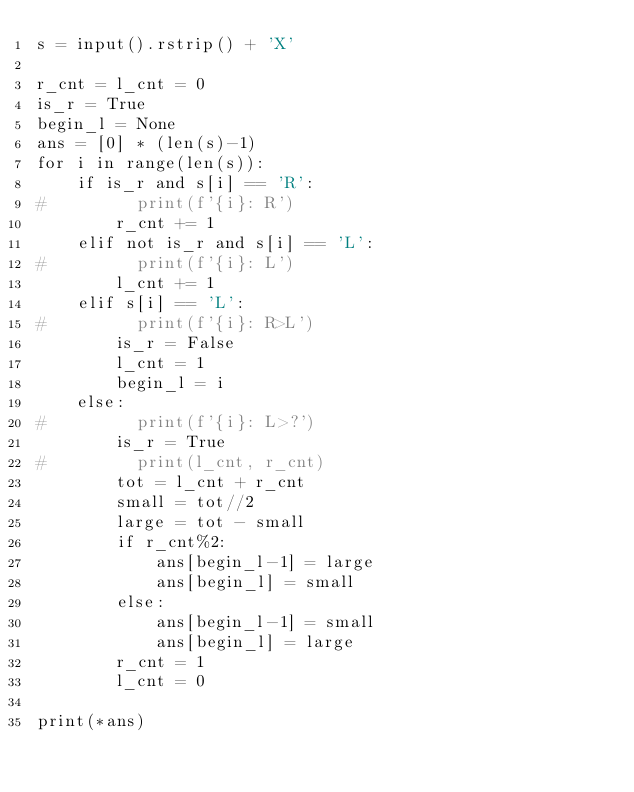Convert code to text. <code><loc_0><loc_0><loc_500><loc_500><_Python_>s = input().rstrip() + 'X'

r_cnt = l_cnt = 0
is_r = True
begin_l = None
ans = [0] * (len(s)-1)
for i in range(len(s)):
    if is_r and s[i] == 'R':
#         print(f'{i}: R')
        r_cnt += 1
    elif not is_r and s[i] == 'L':
#         print(f'{i}: L')
        l_cnt += 1
    elif s[i] == 'L':
#         print(f'{i}: R>L')
        is_r = False
        l_cnt = 1
        begin_l = i
    else:
#         print(f'{i}: L>?')
        is_r = True
#         print(l_cnt, r_cnt)
        tot = l_cnt + r_cnt
        small = tot//2
        large = tot - small
        if r_cnt%2:
            ans[begin_l-1] = large 
            ans[begin_l] = small
        else:
            ans[begin_l-1] = small
            ans[begin_l] = large
        r_cnt = 1
        l_cnt = 0

print(*ans)</code> 